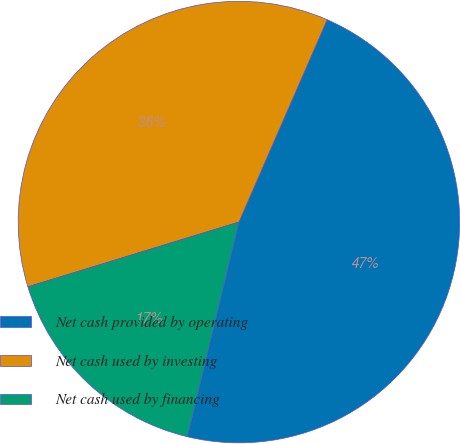<chart> <loc_0><loc_0><loc_500><loc_500><pie_chart><fcel>Net cash provided by operating<fcel>Net cash used by investing<fcel>Net cash used by financing<nl><fcel>47.21%<fcel>36.28%<fcel>16.51%<nl></chart> 